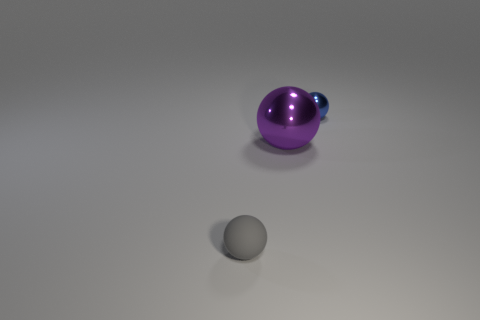What is the color of the large thing that is the same shape as the small rubber object?
Provide a short and direct response. Purple. Do the small shiny thing and the big purple thing have the same shape?
Your answer should be compact. Yes. Are any tiny yellow shiny spheres visible?
Your response must be concise. No. There is a purple metallic sphere that is in front of the tiny ball that is behind the small rubber object; how many tiny spheres are in front of it?
Your answer should be very brief. 1. There is a gray thing; is its shape the same as the tiny object that is behind the small rubber object?
Your response must be concise. Yes. Is the number of small green cubes greater than the number of purple metal balls?
Provide a short and direct response. No. Is there anything else that has the same size as the rubber thing?
Your response must be concise. Yes. There is a small thing to the left of the small blue shiny ball; is its shape the same as the tiny blue metal object?
Offer a very short reply. Yes. Are there more things that are behind the tiny rubber ball than objects?
Offer a terse response. No. The small object in front of the metallic thing that is right of the big purple ball is what color?
Your answer should be compact. Gray. 